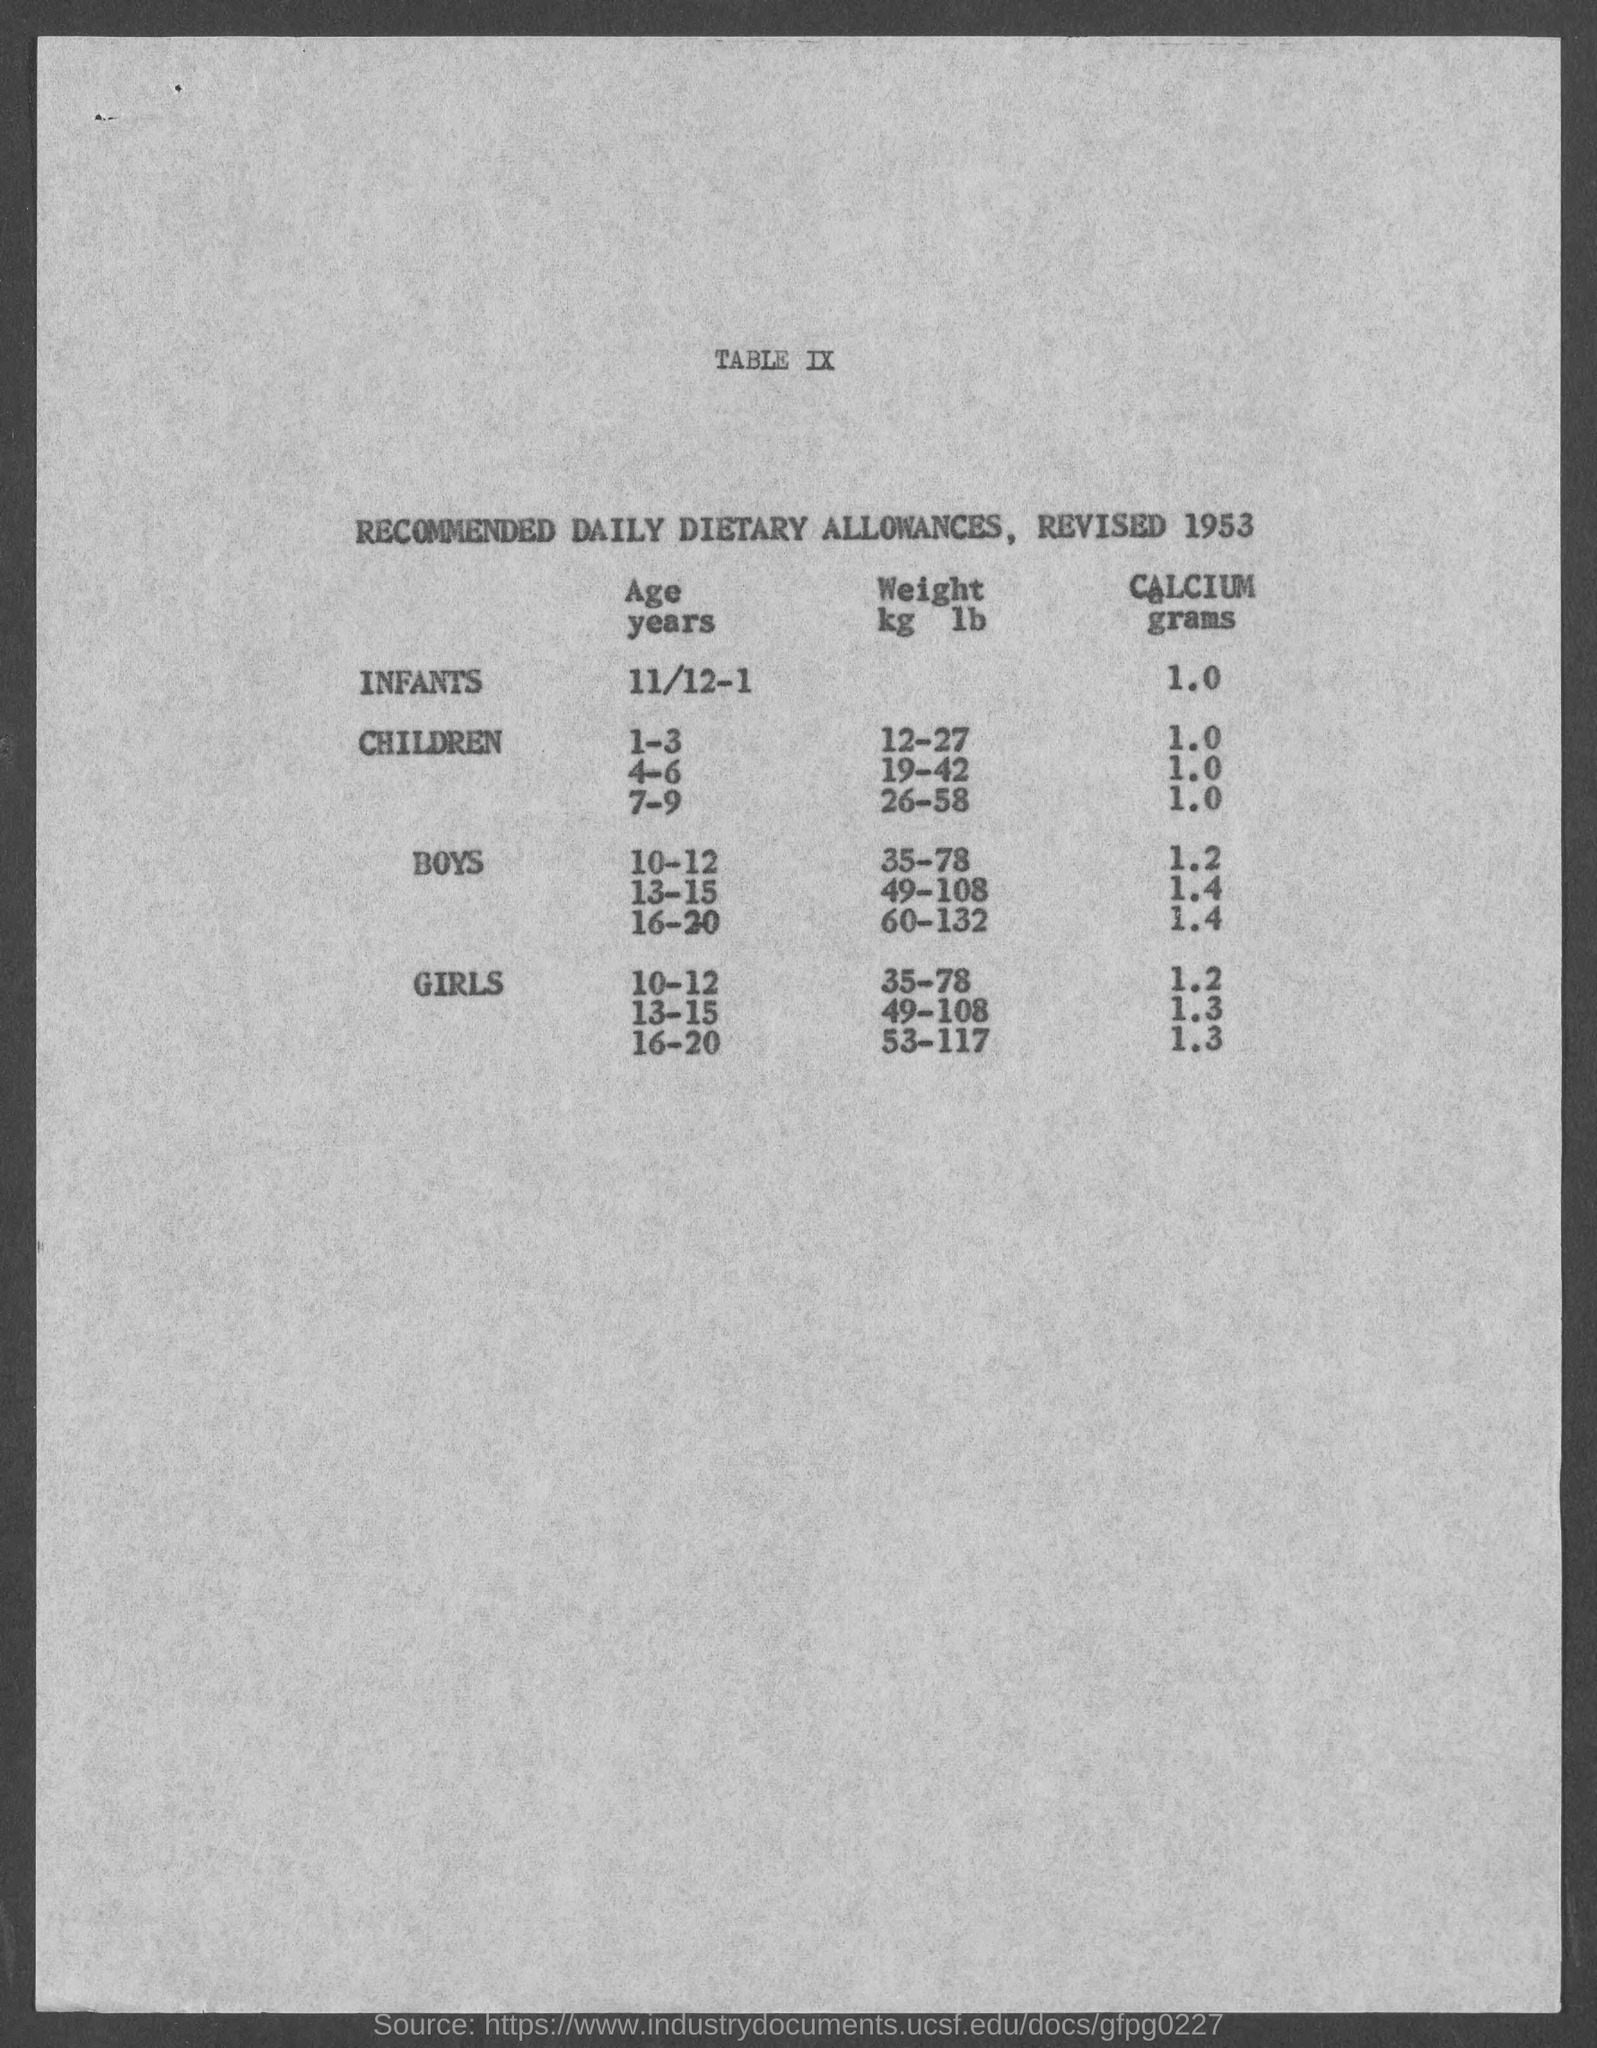Identify some key points in this picture. Recommended grams of calcium for girls in the age group 10-12 is 1200 mg per day. The recommended amount of calcium for boys in the age group of 16-20 is 1.4 grams. The recommended weight for boys in the age group of 10-12, based on height, varies from 35 to 78 kilograms (kg) or pounds (lb). For children in the age group of 1-3, the recommended weight is typically between 2.5 to 8.8 kilograms (kg) or 5.5 to 19.8 pounds (lb). For children in the age group of 12-27, the recommended weight is typically between 17.5 to 32.5 kg or 38.6 to 71.6 lb. The recommended weight for children in the age group of 7-9, ranging from 26-58 kilograms (kg) or pounds (lb), is typically within a healthy range for their age and height. 